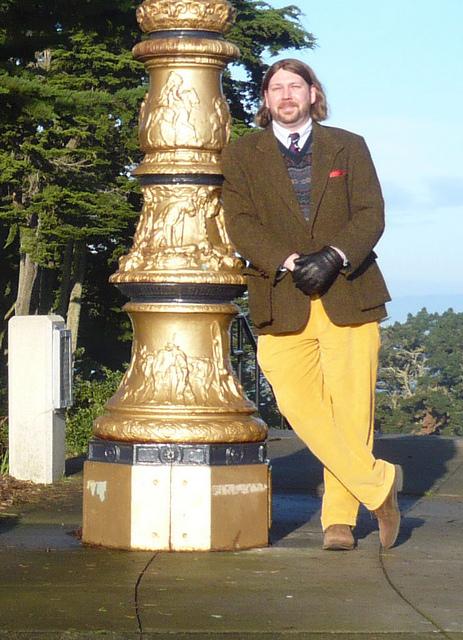Why is the man wearing leather gloves?
Concise answer only. It is cold. Is the person in the photo wearing gloves?
Be succinct. Yes. What is the gold object the man is leaning on?
Concise answer only. Statue. 